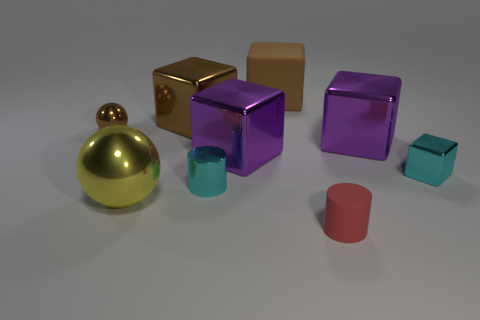How does the lighting in this image affect the appearance of the objects? The lighting in the image seems to be soft and diffused, likely coming from multiple angles, as there are subtle shadows under the objects. This lighting enhances the reflective properties of the glossy objects, making them appear more lustrous, while softer-textured surfaces absorb the light, giving them a muted sheen. 